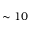<formula> <loc_0><loc_0><loc_500><loc_500>\sim 1 0</formula> 